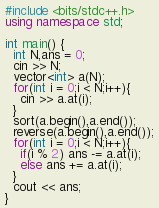<code> <loc_0><loc_0><loc_500><loc_500><_C++_>#include <bits/stdc++.h>
using namespace std;

int main() {
  int N,ans = 0;
  cin >> N;
  vector<int> a(N);
  for(int i = 0;i < N;i++){
    cin >> a.at(i);
  }
  sort(a.begin(),a.end());
  reverse(a.begin(),a.end());
  for(int i = 0;i < N;i++){
    if(i % 2) ans -= a.at(i);
    else ans += a.at(i);
  }
  cout << ans;
}</code> 